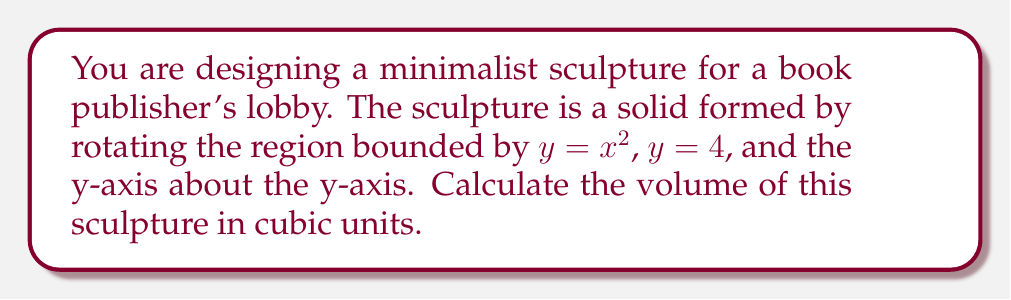Help me with this question. To find the volume of this solid of revolution, we'll use the shell method of integration:

1) The shell method formula is:
   $$V = 2\pi \int_a^b x f(x) dx$$

2) In this case, $f(x) = 4 - x^2$, as we're rotating the region between $y = 4$ and $y = x^2$.

3) The limits of integration are from $x = 0$ to $x = 2$ (where $x^2 = 4$).

4) Substituting into the formula:
   $$V = 2\pi \int_0^2 x(4-x^2) dx$$

5) Expanding:
   $$V = 2\pi \int_0^2 (4x - x^3) dx$$

6) Integrating:
   $$V = 2\pi \left[2x^2 - \frac{1}{4}x^4\right]_0^2$$

7) Evaluating the definite integral:
   $$V = 2\pi \left[(2(2)^2 - \frac{1}{4}(2)^4) - (2(0)^2 - \frac{1}{4}(0)^4)\right]$$
   $$V = 2\pi \left[8 - 4 - 0\right]$$
   $$V = 2\pi(4)$$
   $$V = 8\pi$$

Therefore, the volume of the sculpture is $8\pi$ cubic units.
Answer: $8\pi$ cubic units 